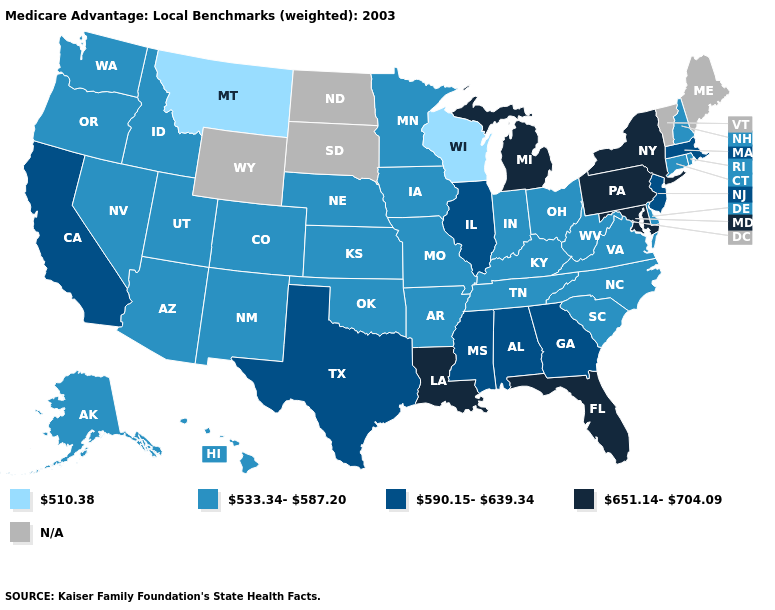Among the states that border Wyoming , does Montana have the highest value?
Give a very brief answer. No. Does Mississippi have the lowest value in the USA?
Write a very short answer. No. What is the value of South Carolina?
Short answer required. 533.34-587.20. What is the value of Nevada?
Concise answer only. 533.34-587.20. Which states have the highest value in the USA?
Concise answer only. Florida, Louisiana, Maryland, Michigan, New York, Pennsylvania. What is the value of North Dakota?
Quick response, please. N/A. What is the value of Georgia?
Write a very short answer. 590.15-639.34. What is the value of Michigan?
Be succinct. 651.14-704.09. Does the first symbol in the legend represent the smallest category?
Be succinct. Yes. Does the first symbol in the legend represent the smallest category?
Keep it brief. Yes. Name the states that have a value in the range 533.34-587.20?
Quick response, please. Alaska, Arkansas, Arizona, Colorado, Connecticut, Delaware, Hawaii, Iowa, Idaho, Indiana, Kansas, Kentucky, Minnesota, Missouri, North Carolina, Nebraska, New Hampshire, New Mexico, Nevada, Ohio, Oklahoma, Oregon, Rhode Island, South Carolina, Tennessee, Utah, Virginia, Washington, West Virginia. What is the value of Nebraska?
Keep it brief. 533.34-587.20. What is the lowest value in the USA?
Quick response, please. 510.38. 